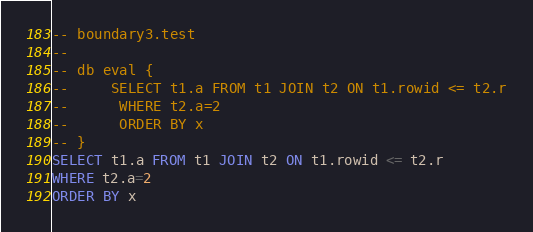Convert code to text. <code><loc_0><loc_0><loc_500><loc_500><_SQL_>-- boundary3.test
-- 
-- db eval {
--     SELECT t1.a FROM t1 JOIN t2 ON t1.rowid <= t2.r
--      WHERE t2.a=2
--      ORDER BY x
-- }
SELECT t1.a FROM t1 JOIN t2 ON t1.rowid <= t2.r
WHERE t2.a=2
ORDER BY x</code> 